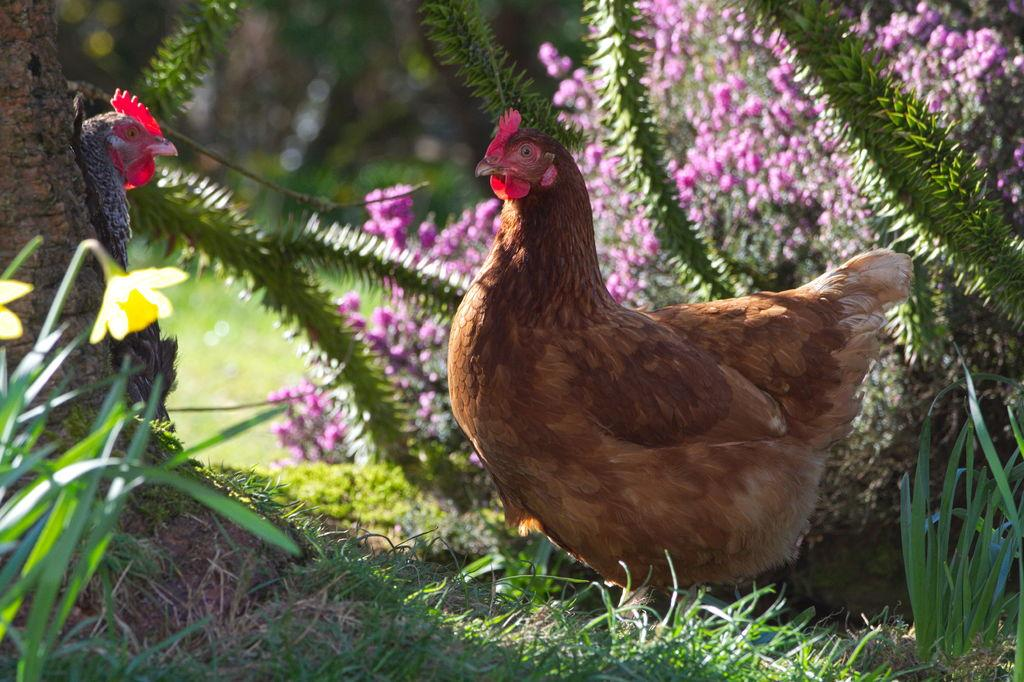What type of animals can be seen in the image? There are hens in the image. What colors of flowers are present in the image? There are purple and yellow color flowers in the image. Are the flowers attached to any plants? Yes, the flowers are on plants. What type of vegetation is visible on the ground in the image? There is grass on the ground in the image. Where is the playground located in the image? There is no playground present in the image. Can you see any water features in the image? There is no water visible in the image. 